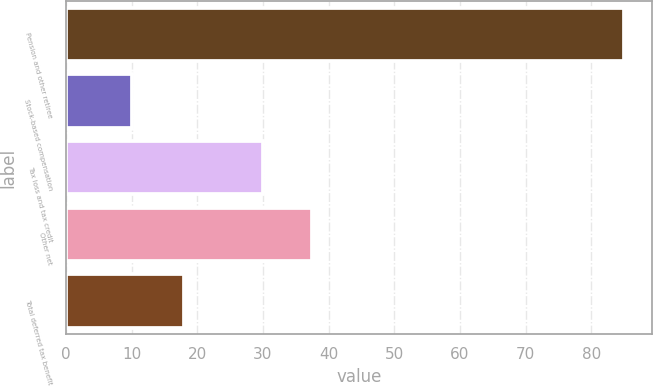<chart> <loc_0><loc_0><loc_500><loc_500><bar_chart><fcel>Pension and other retiree<fcel>Stock-based compensation<fcel>Tax loss and tax credit<fcel>Other net<fcel>Total deferred tax benefit<nl><fcel>85<fcel>10<fcel>30<fcel>37.5<fcel>18<nl></chart> 